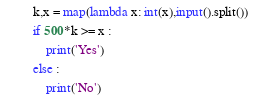<code> <loc_0><loc_0><loc_500><loc_500><_Python_>k,x = map(lambda x: int(x),input().split())
if 500*k >= x :
    print('Yes')
else :
    print('No')
</code> 